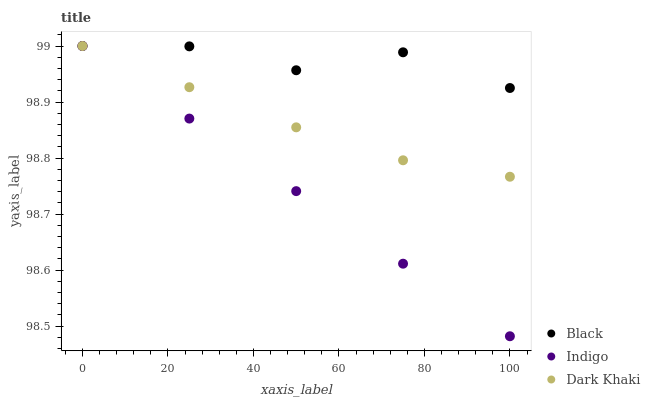Does Indigo have the minimum area under the curve?
Answer yes or no. Yes. Does Black have the maximum area under the curve?
Answer yes or no. Yes. Does Black have the minimum area under the curve?
Answer yes or no. No. Does Indigo have the maximum area under the curve?
Answer yes or no. No. Is Indigo the smoothest?
Answer yes or no. Yes. Is Black the roughest?
Answer yes or no. Yes. Is Black the smoothest?
Answer yes or no. No. Is Indigo the roughest?
Answer yes or no. No. Does Indigo have the lowest value?
Answer yes or no. Yes. Does Black have the lowest value?
Answer yes or no. No. Does Black have the highest value?
Answer yes or no. Yes. Does Indigo intersect Dark Khaki?
Answer yes or no. Yes. Is Indigo less than Dark Khaki?
Answer yes or no. No. Is Indigo greater than Dark Khaki?
Answer yes or no. No. 